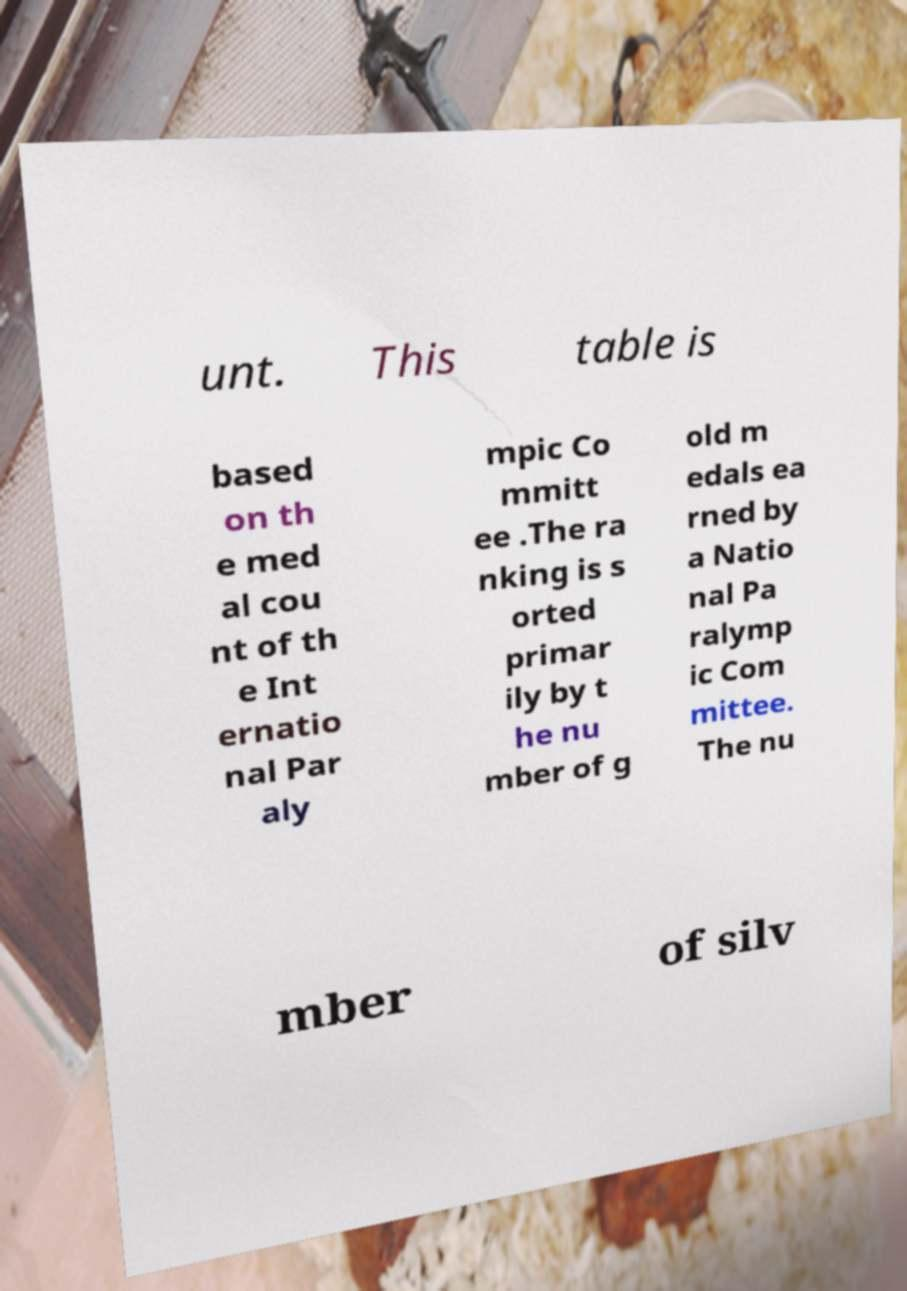Please identify and transcribe the text found in this image. unt. This table is based on th e med al cou nt of th e Int ernatio nal Par aly mpic Co mmitt ee .The ra nking is s orted primar ily by t he nu mber of g old m edals ea rned by a Natio nal Pa ralymp ic Com mittee. The nu mber of silv 